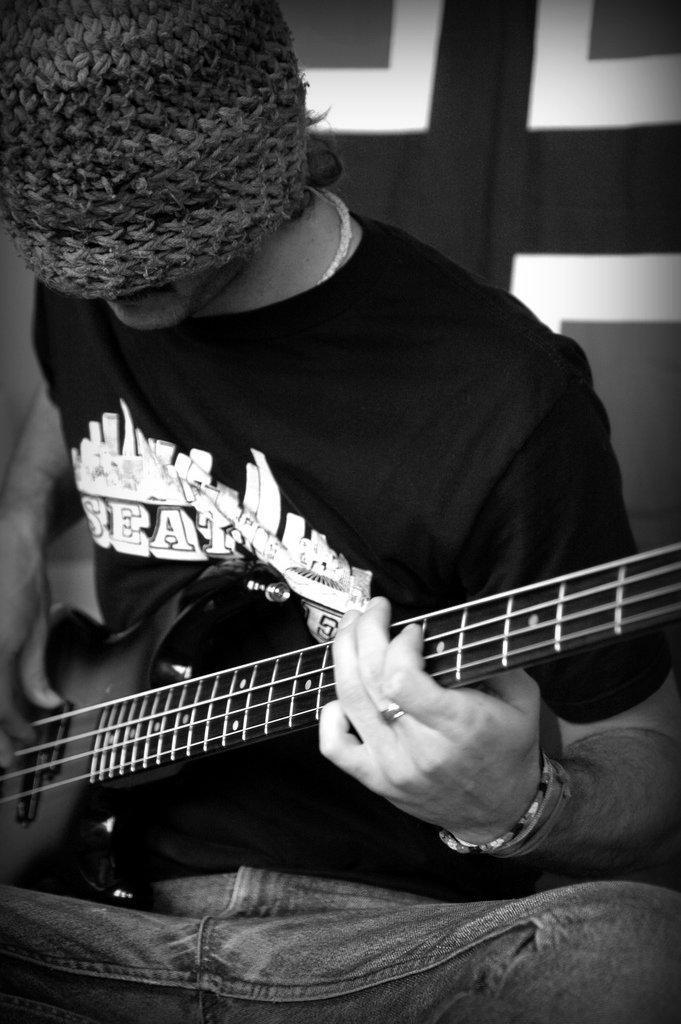In one or two sentences, can you explain what this image depicts? In the picture a person is sitting and wearing a cap he is playing a guitar. 